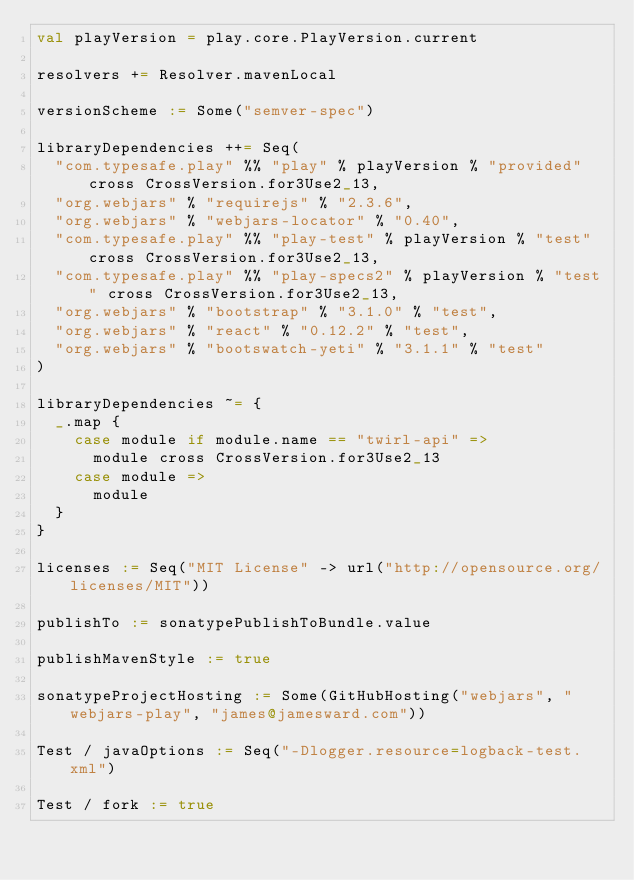Convert code to text. <code><loc_0><loc_0><loc_500><loc_500><_Scala_>val playVersion = play.core.PlayVersion.current

resolvers += Resolver.mavenLocal

versionScheme := Some("semver-spec")

libraryDependencies ++= Seq(
  "com.typesafe.play" %% "play" % playVersion % "provided" cross CrossVersion.for3Use2_13,
  "org.webjars" % "requirejs" % "2.3.6",
  "org.webjars" % "webjars-locator" % "0.40",
  "com.typesafe.play" %% "play-test" % playVersion % "test" cross CrossVersion.for3Use2_13,
  "com.typesafe.play" %% "play-specs2" % playVersion % "test" cross CrossVersion.for3Use2_13,
  "org.webjars" % "bootstrap" % "3.1.0" % "test",
  "org.webjars" % "react" % "0.12.2" % "test",
  "org.webjars" % "bootswatch-yeti" % "3.1.1" % "test"
)

libraryDependencies ~= {
  _.map {
    case module if module.name == "twirl-api" =>
      module cross CrossVersion.for3Use2_13
    case module =>
      module
  }
}

licenses := Seq("MIT License" -> url("http://opensource.org/licenses/MIT"))

publishTo := sonatypePublishToBundle.value

publishMavenStyle := true

sonatypeProjectHosting := Some(GitHubHosting("webjars", "webjars-play", "james@jamesward.com"))

Test / javaOptions := Seq("-Dlogger.resource=logback-test.xml")

Test / fork := true
</code> 